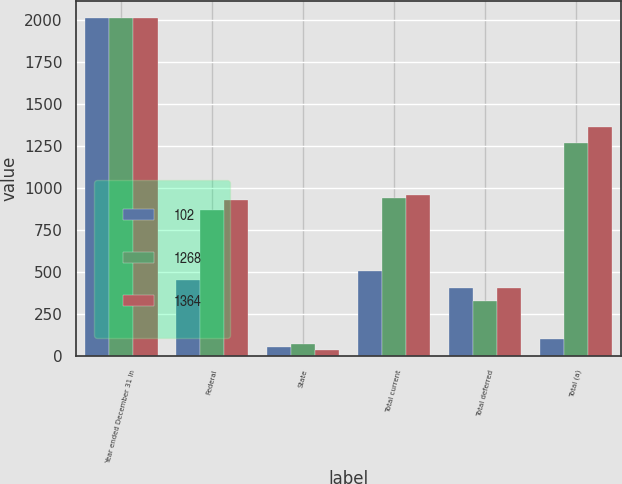<chart> <loc_0><loc_0><loc_500><loc_500><stacked_bar_chart><ecel><fcel>Year ended December 31 In<fcel>Federal<fcel>State<fcel>Total current<fcel>Total deferred<fcel>Total (a)<nl><fcel>102<fcel>2017<fcel>454<fcel>51<fcel>505<fcel>403<fcel>102<nl><fcel>1268<fcel>2016<fcel>871<fcel>71<fcel>942<fcel>326<fcel>1268<nl><fcel>1364<fcel>2015<fcel>927<fcel>33<fcel>960<fcel>404<fcel>1364<nl></chart> 